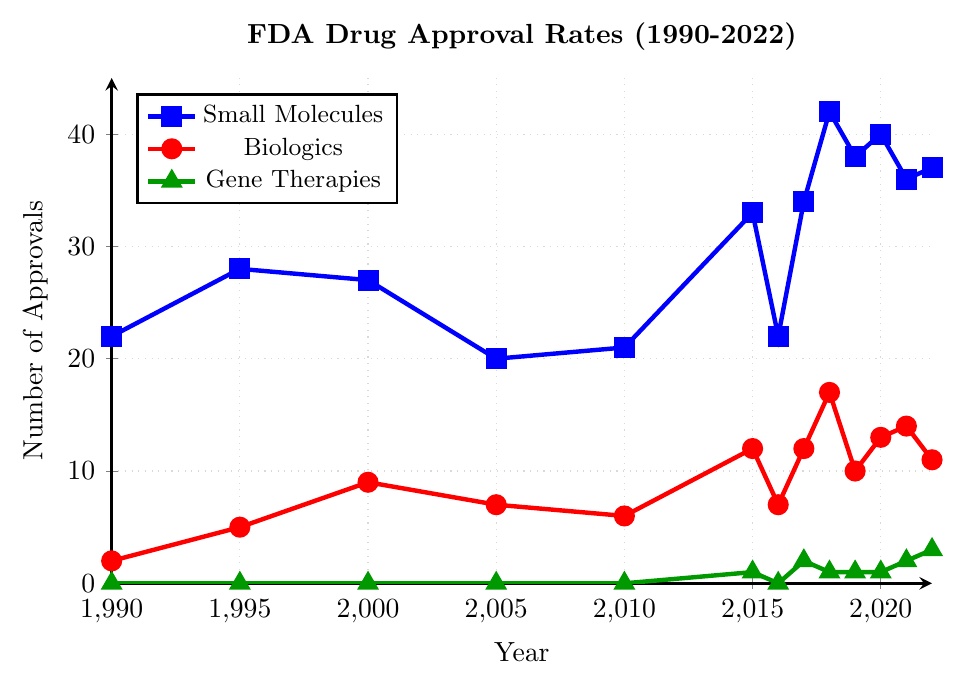How did the approval rates for small molecules change from 1990 to 2022? From the plot, find the points for small molecules in 1990 and 2022 and compare them. In 1990, small molecules had 22 approvals and in 2022, they had 37 approvals. Calculate the change by subtracting the 1990 value from the 2022 value: 37 - 22 = 15.
Answer: Increased by 15 Which year had the highest number of approvals for biologics? Check the red line representing biologics and find the highest point on the chart. The highest point is in the year 2018 with 17 approvals.
Answer: 2018 How many years had more than 30 small molecule approvals? Identify the points on the blue line representing small molecules where the approval numbers are greater than 30. These years are 2015 (33), 2017 (34), 2018 (42), 2019 (38), 2020 (40), 2021 (36), and 2022 (37). Count these points: 7 years.
Answer: 7 What is the average approval rate for gene therapies from 2015 to 2022? Locate the green line from 2015 to 2022 and note the approval counts: 1, 0, 2, 1, 1, 1, 2, 3. Sum these values: 1 + 0 + 2 + 1 + 1 + 1 + 2 + 3 = 11. The number of years is 8. Divide the total by the number of years: 11 / 8 = 1.375.
Answer: 1.375 How did biologic approvals in 2010 compare to 2020? Find the number of biologic approvals in 2010 (6) and in 2020 (13). Calculate the difference: 13 - 6 = 7. The approvals in 2020 are 7 more than in 2010.
Answer: Increased by 7 Between which two consecutive years did small molecules see the largest increase in approvals? Examine the blue line and calculate the year-on-year differences: (28-22)=6, (27-28)=-1, (20-27)=-7, (21-20)=1, (33-21)=12, (22-33)=-11, (34-22)=12, (42-34)=8, (38-42)=-4, (40-38)=2, (36-40)=-4, (37-36)=1. The largest increase is from 2014 to 2015 and 2016 to 2017, both with 12.
Answer: 2014 to 2015 and 2016 to 2017 Which drug type had the smallest variation in approval numbers from 1990 to 2022? Assess the overall fluctuations in the plot for each type. Small molecules range from 20 to 42 (variation: 22), biologics range from 2 to 17 (variation: 15), gene therapies range from 0 to 3 (variation: 3). Gene therapies have the smallest range.
Answer: Gene therapies 